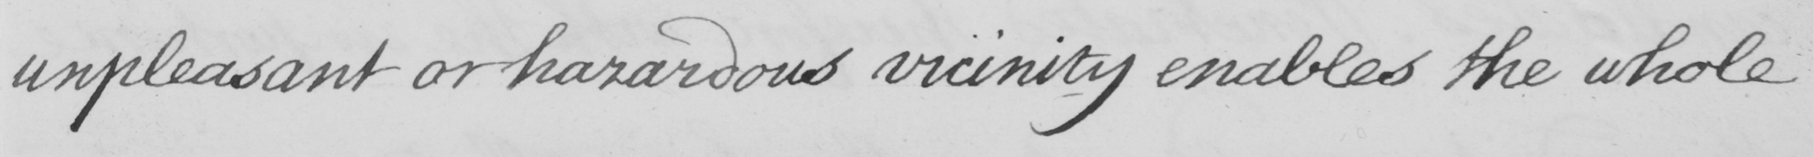What text is written in this handwritten line? unpleasant or hazardous vicinity enables the whole 